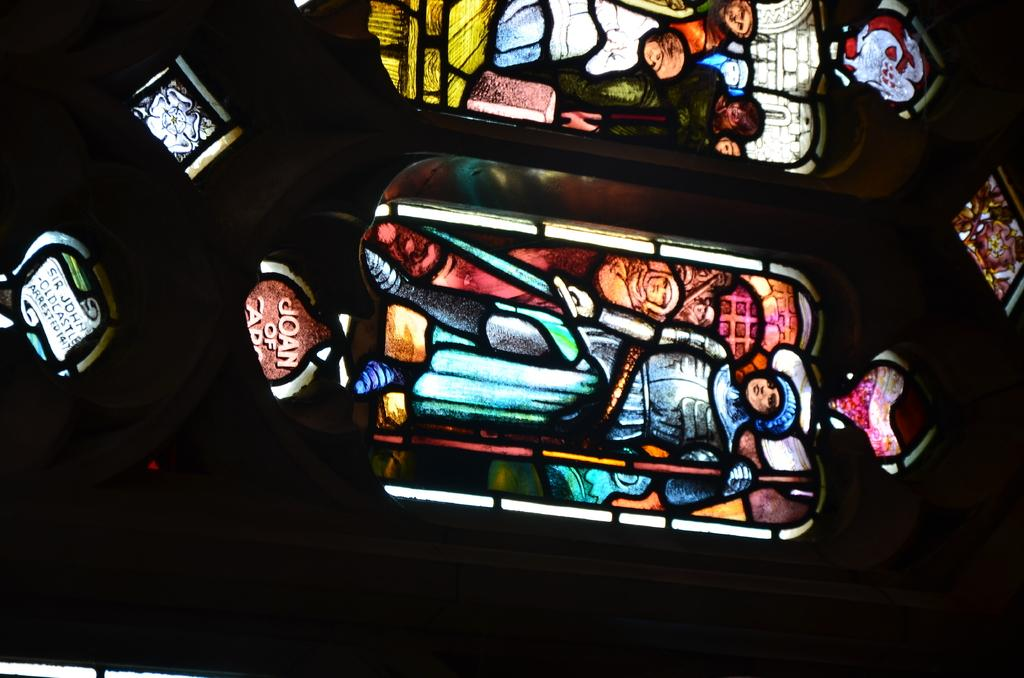How many windows are visible in the image? There are two windows in the image. What is depicted on the windows? There are images of people on the windows. What can be observed about the background of the image? The background of the image is dark. What is the rate of the fictional man's progress in the image? There is no fictional man present in the image, and therefore no rate of progress can be determined. 